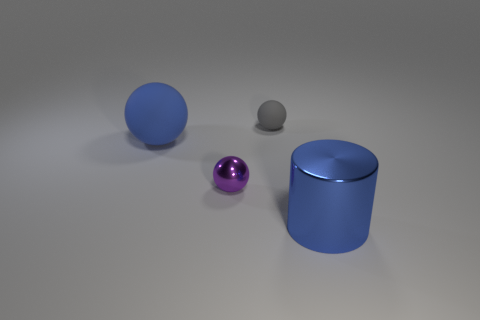There is a gray ball; is its size the same as the blue thing in front of the purple metallic thing?
Offer a very short reply. No. What color is the big metal cylinder?
Offer a terse response. Blue. There is a large blue object that is to the right of the shiny thing that is on the left side of the shiny object right of the gray sphere; what is its shape?
Make the answer very short. Cylinder. What is the material of the large thing to the left of the blue object right of the purple ball?
Offer a very short reply. Rubber. The big blue object that is made of the same material as the small purple sphere is what shape?
Ensure brevity in your answer.  Cylinder. Are there any other things that are the same shape as the tiny gray object?
Your response must be concise. Yes. What number of blue things are on the left side of the big shiny cylinder?
Your answer should be compact. 1. Are there any large metallic objects?
Provide a succinct answer. Yes. What color is the metal object that is left of the gray object behind the matte sphere left of the gray matte object?
Provide a short and direct response. Purple. Is there a large blue sphere that is on the left side of the large shiny cylinder in front of the small metallic thing?
Your answer should be very brief. Yes. 